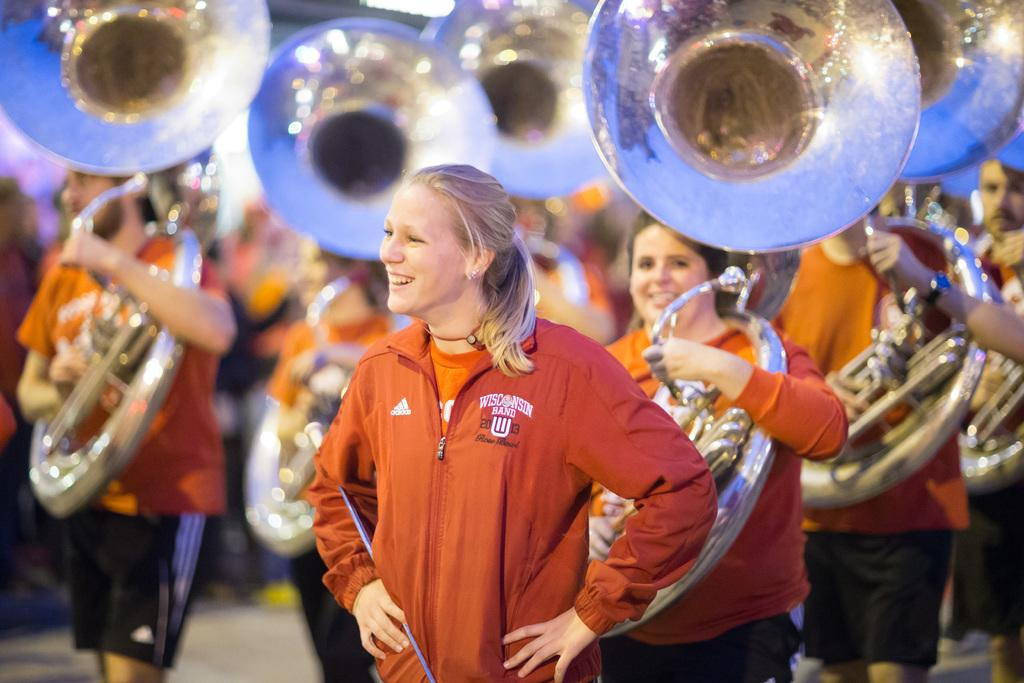Who is the main subject in the foreground of the image? There is a woman in the foreground of the image. What is the woman doing in the image? The woman is laughing. What are the people in the background of the image doing? The people in the background are playing music instruments. Can you compare the thickness of the fog in the image to the thickness of the fog in another image? There is no fog present in the image, so it cannot be compared to the thickness of fog in another image. 